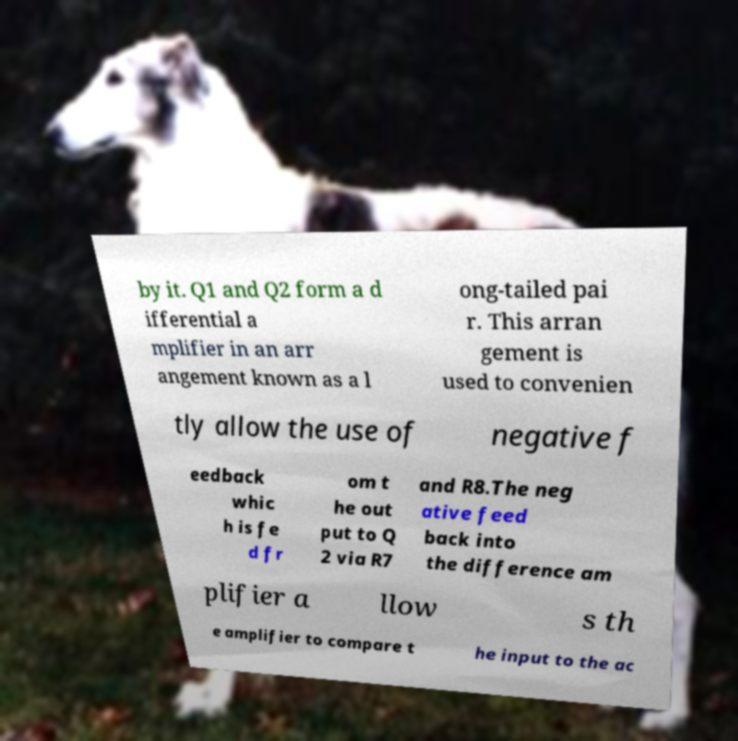I need the written content from this picture converted into text. Can you do that? by it. Q1 and Q2 form a d ifferential a mplifier in an arr angement known as a l ong-tailed pai r. This arran gement is used to convenien tly allow the use of negative f eedback whic h is fe d fr om t he out put to Q 2 via R7 and R8.The neg ative feed back into the difference am plifier a llow s th e amplifier to compare t he input to the ac 